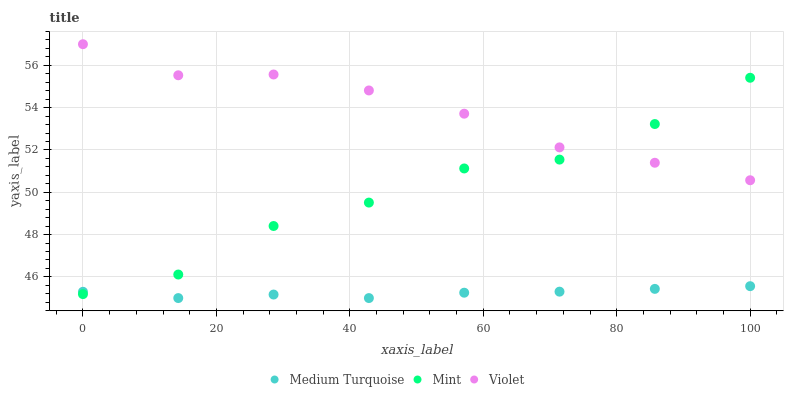Does Medium Turquoise have the minimum area under the curve?
Answer yes or no. Yes. Does Violet have the maximum area under the curve?
Answer yes or no. Yes. Does Violet have the minimum area under the curve?
Answer yes or no. No. Does Medium Turquoise have the maximum area under the curve?
Answer yes or no. No. Is Medium Turquoise the smoothest?
Answer yes or no. Yes. Is Mint the roughest?
Answer yes or no. Yes. Is Violet the smoothest?
Answer yes or no. No. Is Violet the roughest?
Answer yes or no. No. Does Medium Turquoise have the lowest value?
Answer yes or no. Yes. Does Violet have the lowest value?
Answer yes or no. No. Does Violet have the highest value?
Answer yes or no. Yes. Does Medium Turquoise have the highest value?
Answer yes or no. No. Is Medium Turquoise less than Violet?
Answer yes or no. Yes. Is Violet greater than Medium Turquoise?
Answer yes or no. Yes. Does Medium Turquoise intersect Mint?
Answer yes or no. Yes. Is Medium Turquoise less than Mint?
Answer yes or no. No. Is Medium Turquoise greater than Mint?
Answer yes or no. No. Does Medium Turquoise intersect Violet?
Answer yes or no. No. 